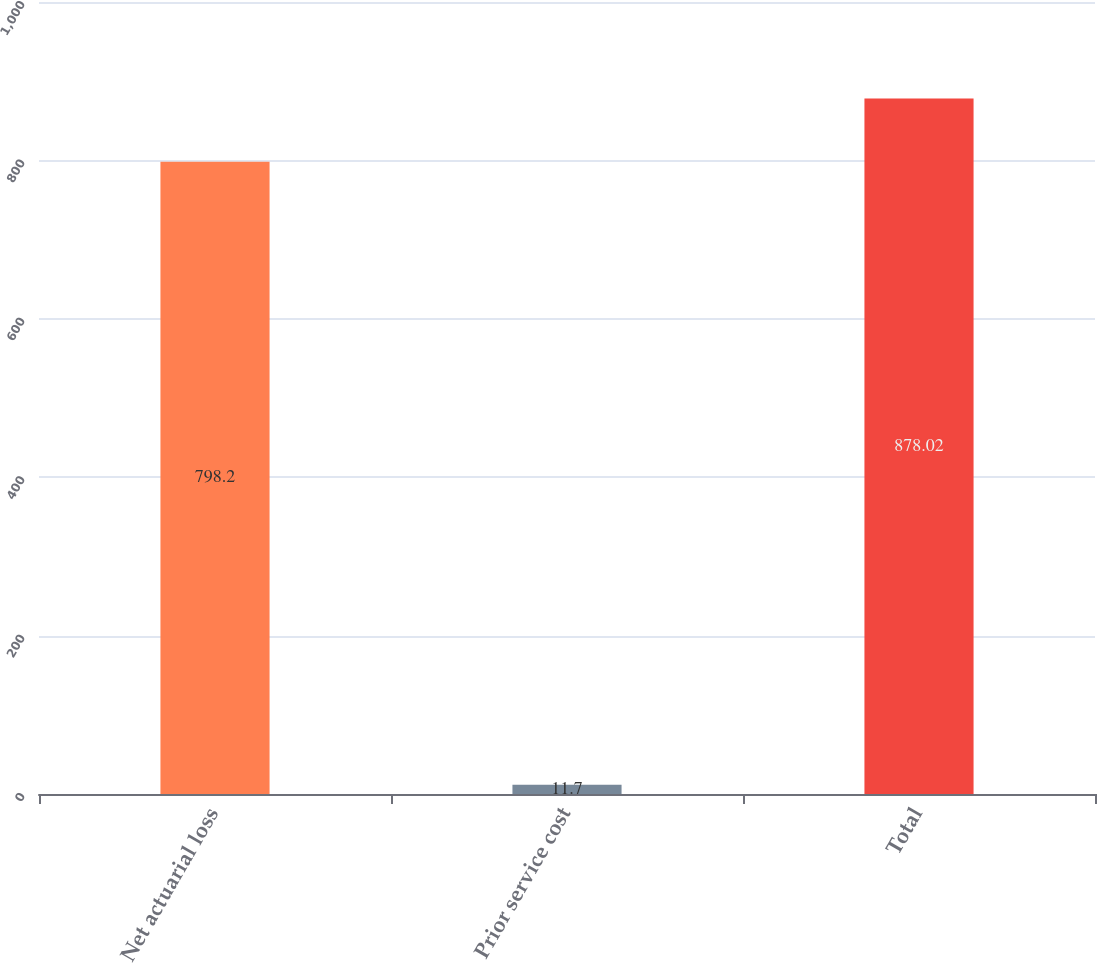Convert chart. <chart><loc_0><loc_0><loc_500><loc_500><bar_chart><fcel>Net actuarial loss<fcel>Prior service cost<fcel>Total<nl><fcel>798.2<fcel>11.7<fcel>878.02<nl></chart> 